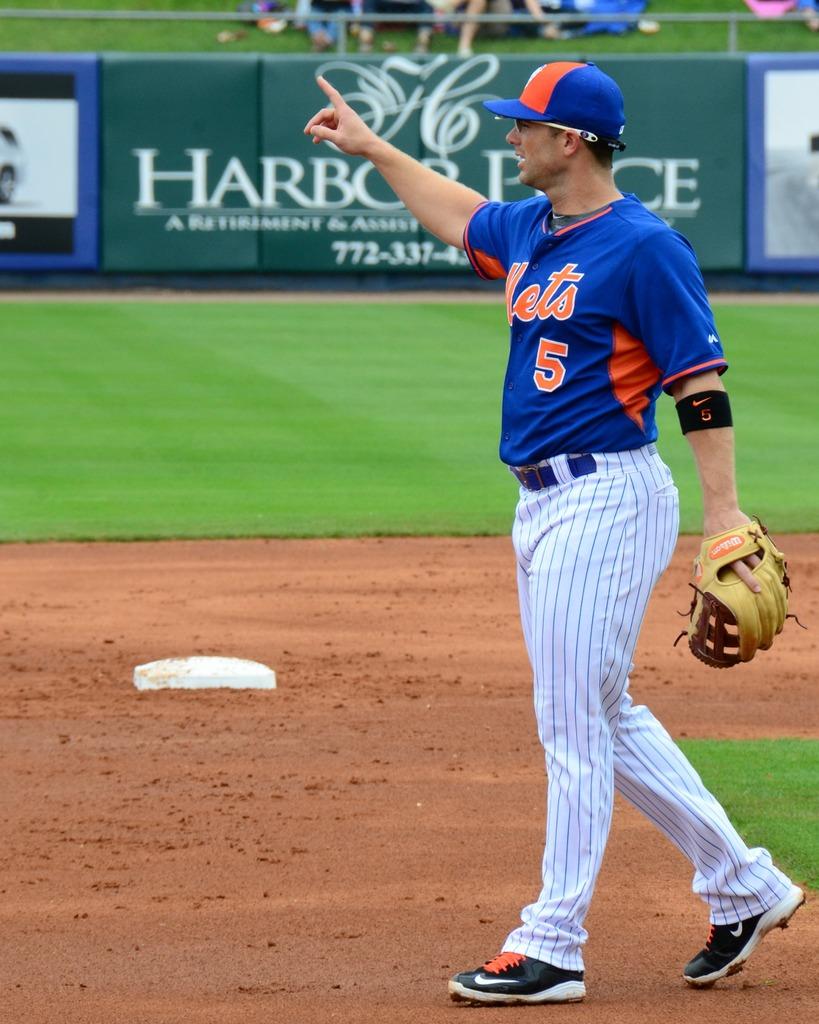Who does the player play for?
Your answer should be compact. Mets. What number is on his shirt?
Your answer should be very brief. 5. 